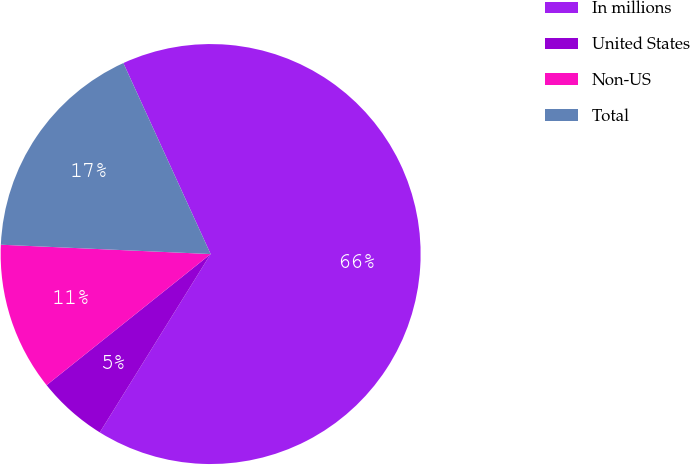Convert chart. <chart><loc_0><loc_0><loc_500><loc_500><pie_chart><fcel>In millions<fcel>United States<fcel>Non-US<fcel>Total<nl><fcel>65.67%<fcel>5.42%<fcel>11.44%<fcel>17.47%<nl></chart> 